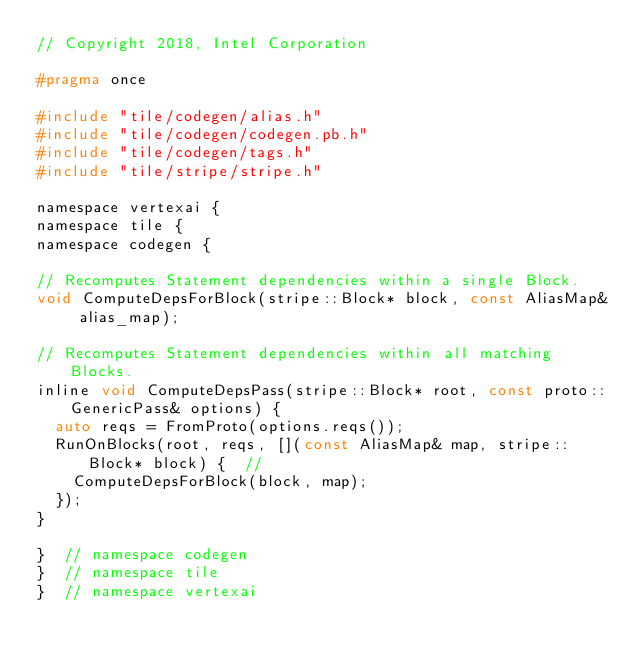<code> <loc_0><loc_0><loc_500><loc_500><_C_>// Copyright 2018, Intel Corporation

#pragma once

#include "tile/codegen/alias.h"
#include "tile/codegen/codegen.pb.h"
#include "tile/codegen/tags.h"
#include "tile/stripe/stripe.h"

namespace vertexai {
namespace tile {
namespace codegen {

// Recomputes Statement dependencies within a single Block.
void ComputeDepsForBlock(stripe::Block* block, const AliasMap& alias_map);

// Recomputes Statement dependencies within all matching Blocks.
inline void ComputeDepsPass(stripe::Block* root, const proto::GenericPass& options) {
  auto reqs = FromProto(options.reqs());
  RunOnBlocks(root, reqs, [](const AliasMap& map, stripe::Block* block) {  //
    ComputeDepsForBlock(block, map);
  });
}

}  // namespace codegen
}  // namespace tile
}  // namespace vertexai
</code> 